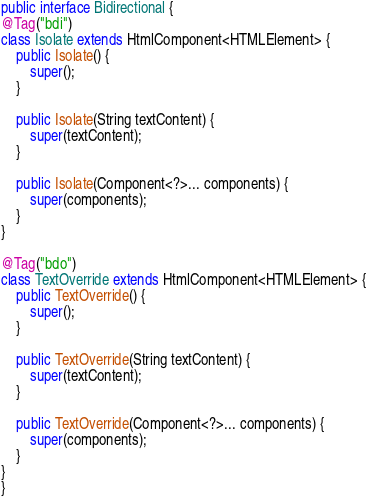Convert code to text. <code><loc_0><loc_0><loc_500><loc_500><_Java_>public interface Bidirectional {
@Tag("bdi")
class Isolate extends HtmlComponent<HTMLElement> {
    public Isolate() {
        super();
    }

    public Isolate(String textContent) {
        super(textContent);
    }

    public Isolate(Component<?>... components) {
        super(components);
    }
}

@Tag("bdo")
class TextOverride extends HtmlComponent<HTMLElement> {
    public TextOverride() {
        super();
    }

    public TextOverride(String textContent) {
        super(textContent);
    }

    public TextOverride(Component<?>... components) {
        super(components);
    }
}
}
</code> 